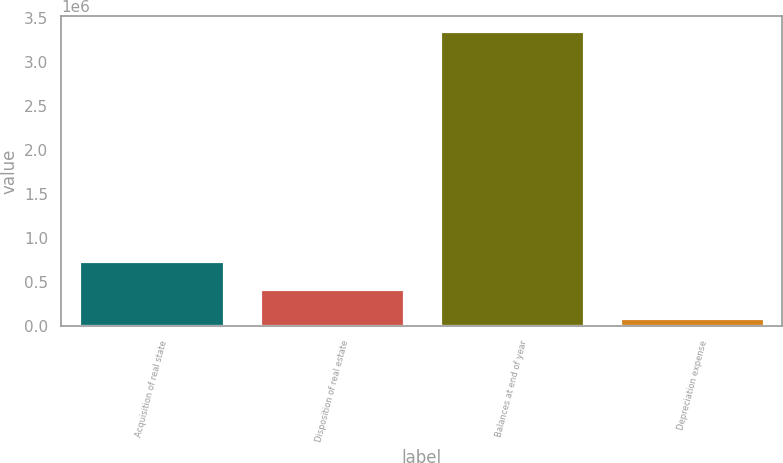Convert chart to OTSL. <chart><loc_0><loc_0><loc_500><loc_500><bar_chart><fcel>Acquisition of real state<fcel>Disposition of real estate<fcel>Balances at end of year<fcel>Depreciation expense<nl><fcel>741027<fcel>414788<fcel>3.35094e+06<fcel>88548<nl></chart> 